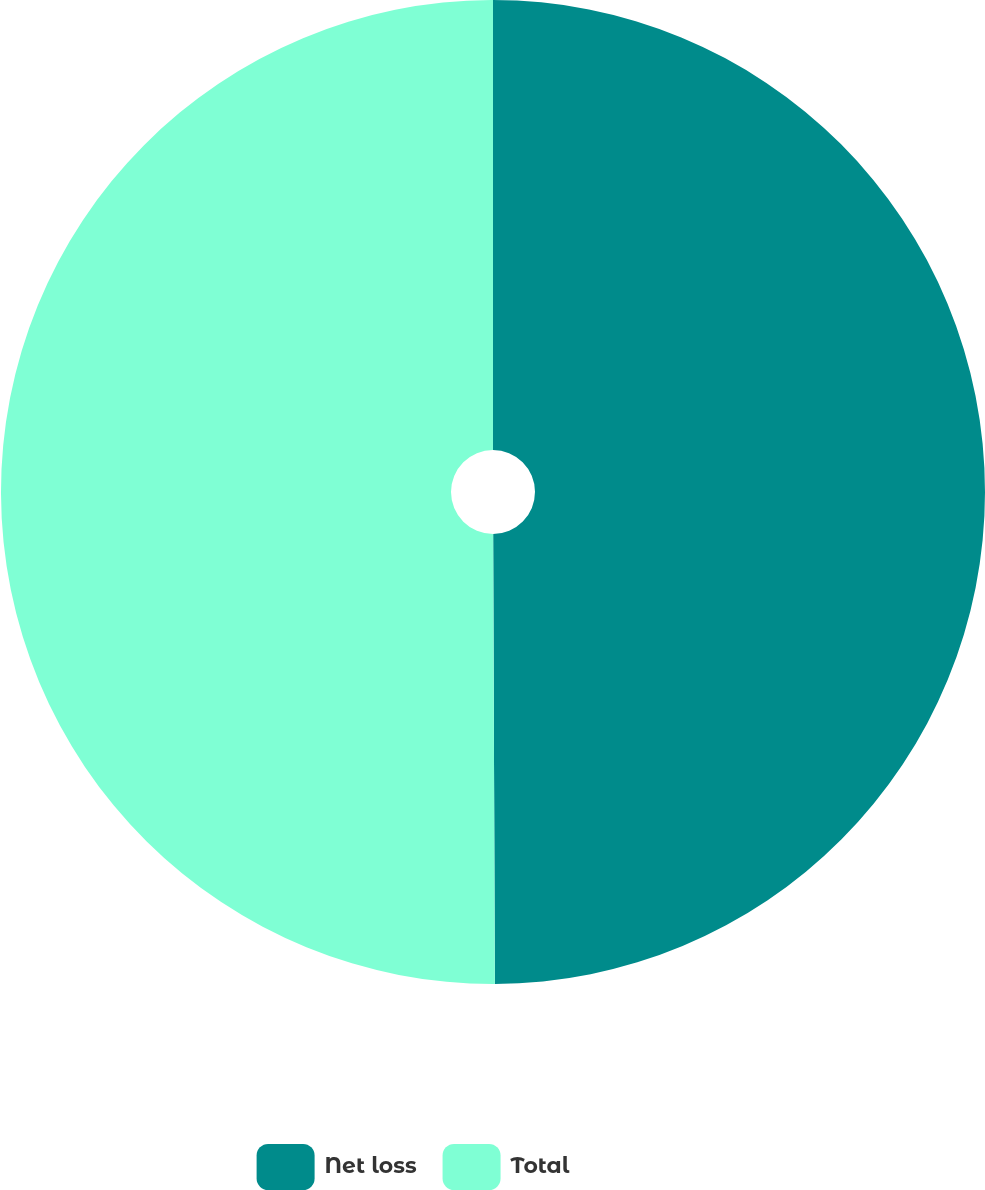Convert chart to OTSL. <chart><loc_0><loc_0><loc_500><loc_500><pie_chart><fcel>Net loss<fcel>Total<nl><fcel>49.94%<fcel>50.06%<nl></chart> 